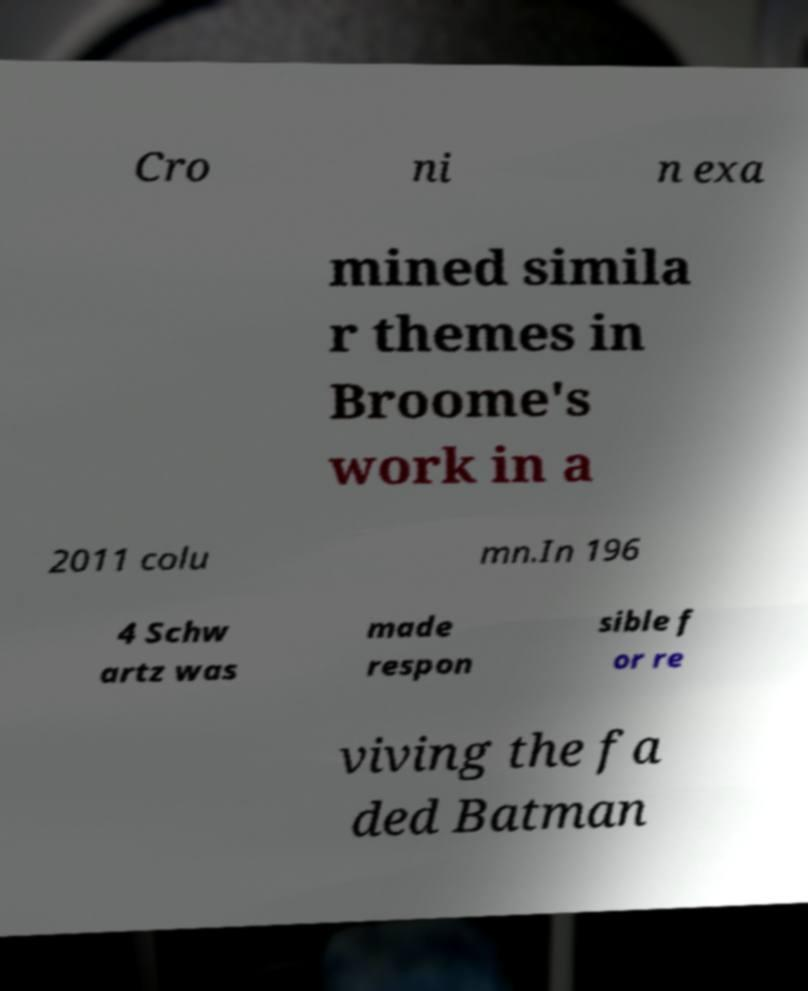What messages or text are displayed in this image? I need them in a readable, typed format. Cro ni n exa mined simila r themes in Broome's work in a 2011 colu mn.In 196 4 Schw artz was made respon sible f or re viving the fa ded Batman 